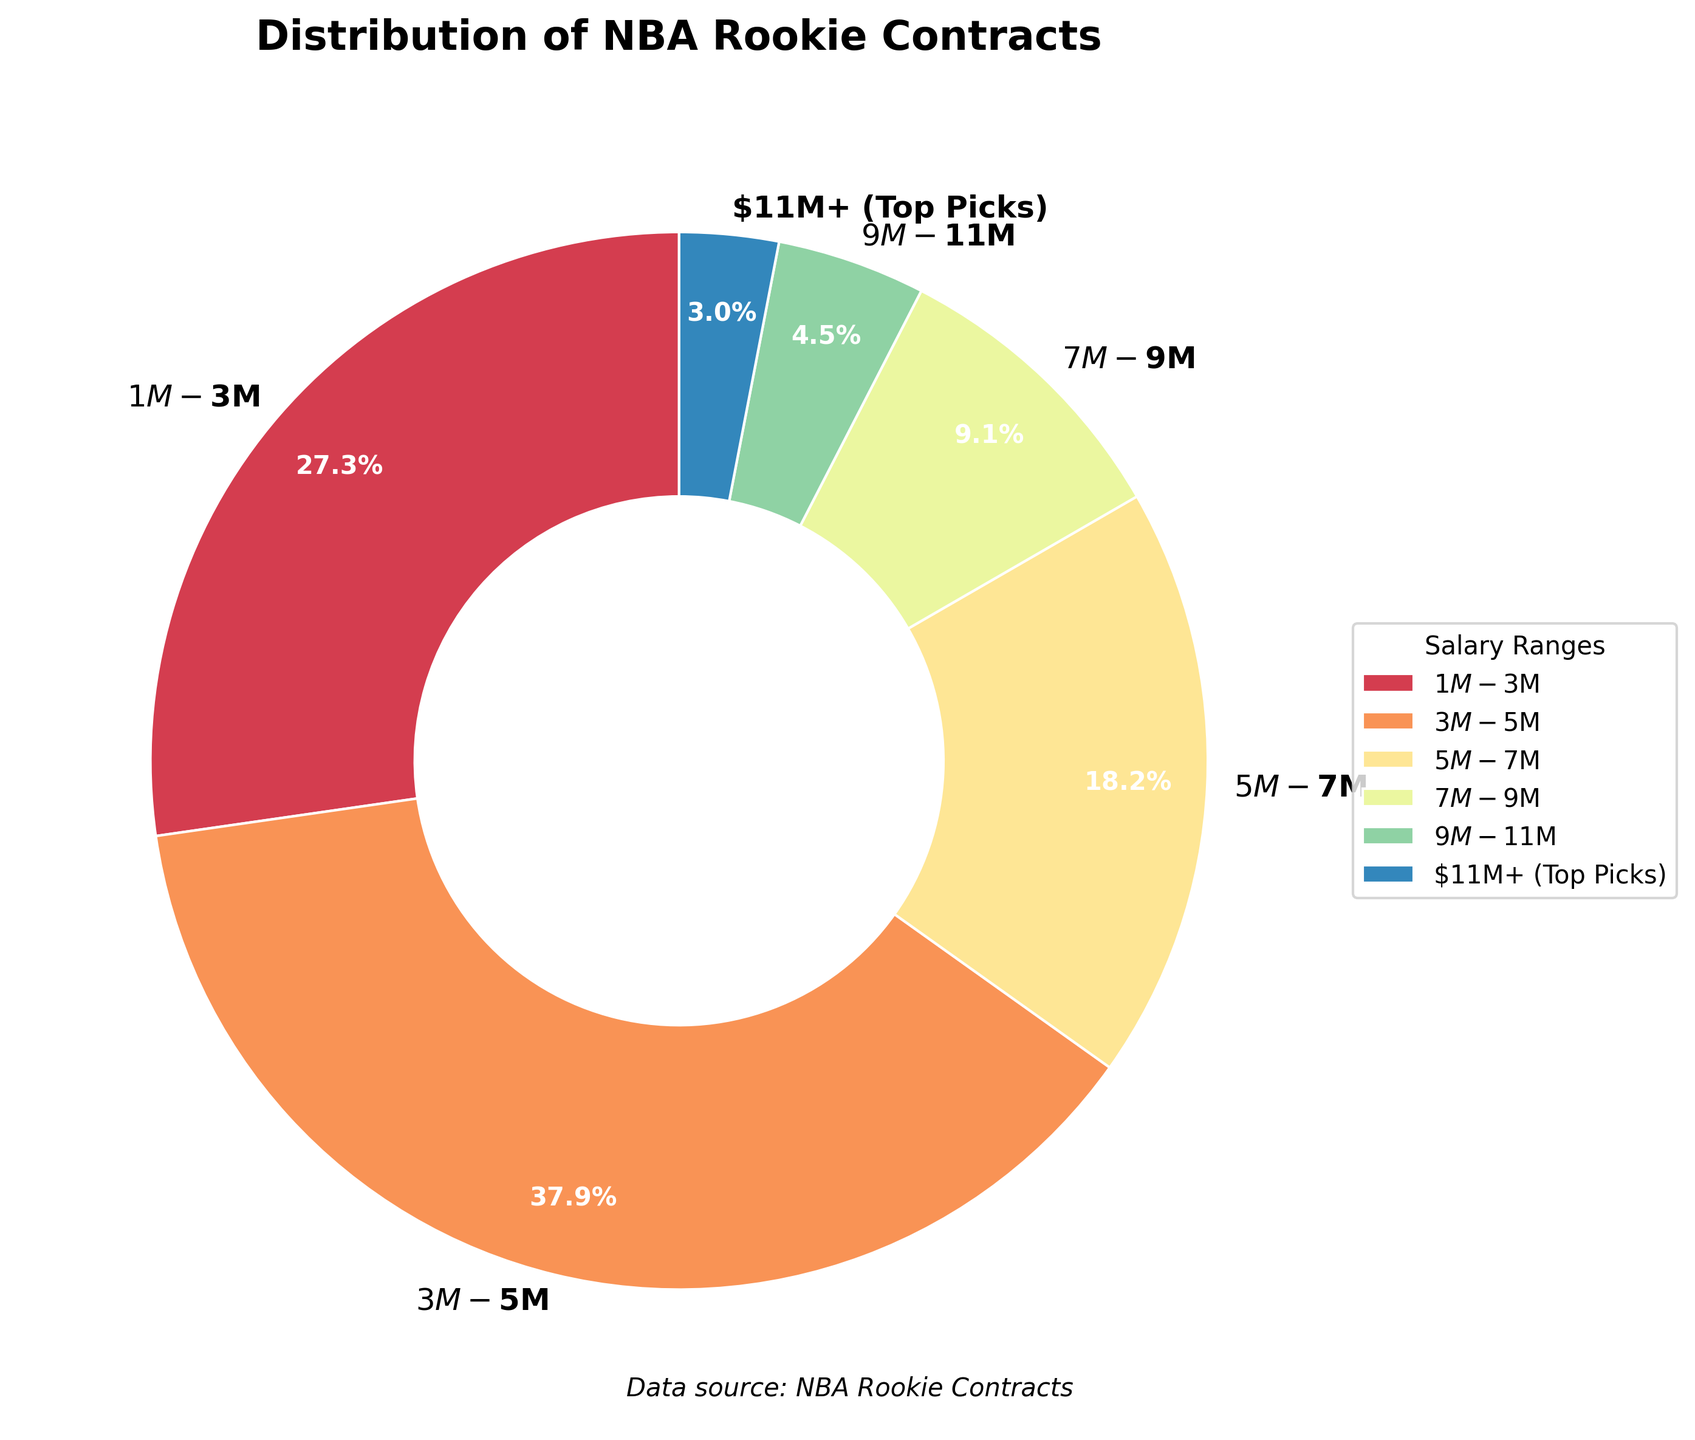What percentage of NBA rookies have contracts in the $3M - $5M range? The percentage is given directly on the pie chart segment for the $3M - $5M range. Look at the value in this segment of the chart.
Answer: 34.7% Which salary range has the fewest number of rookies? Identify the smallest segment in the pie chart, which represents the salary range with the fewest players.
Answer: $11M+ (Top Picks) How many more players are in the $3M - $5M range compared to the $7M - $9M range? Subtract the number of players in the $7M - $9M range from the number of players in the $3M - $5M range. 25 - 6 = 19
Answer: 19 What is the combined percentage of players in the $1M - $3M and $5M - $7M ranges? Add the percentages of the $1M - $3M and $5M - $7M ranges shown on the pie chart. 25.0% + 16.7%
Answer: 41.7% Do more players have salaries above $9M or below $9M? Sum the percentages for the salary ranges above $9M and compare them with the sum of the percentages for the salary ranges below $9M. Above $9M: 5.6% + 2.8% = 8.4%; Below $9M: 25.0% + 34.7% + 16.7% + 8.3% = 84.7%
Answer: Below $9M What is the total number of players in the $5M - $11M ranges combined? Add the number of players in the $5M - $7M, $7M - $9M, and $9M - $11M ranges. 12 + 6 + 3 = 21
Answer: 21 Which salary range has the largest segment color, and what is the color? Identify the largest segment in the pie chart and note its color. Largest segment is $3M - $5M, and the color is in the blue shades.
Answer: $3M - $5M, blue shades Is the percentage of rookies in the $1M - $3M range greater than that in the $7M - $9M range? Compare the percentages given for the $1M - $3M and $7M - $9M ranges. $1M - $3M: 25.0%; $7M - $9M: 8.3%
Answer: Yes, greater What is the average number of players in the salary ranges below $9M? First, total the number of players in the $1M - $3M, $3M - $5M, and $5M - $7M ranges, then divide by the number of these ranges. (18 + 25 + 12) / 3 = 55 / 3
Answer: 18.3 